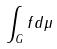<formula> <loc_0><loc_0><loc_500><loc_500>\int _ { G } f d \mu</formula> 